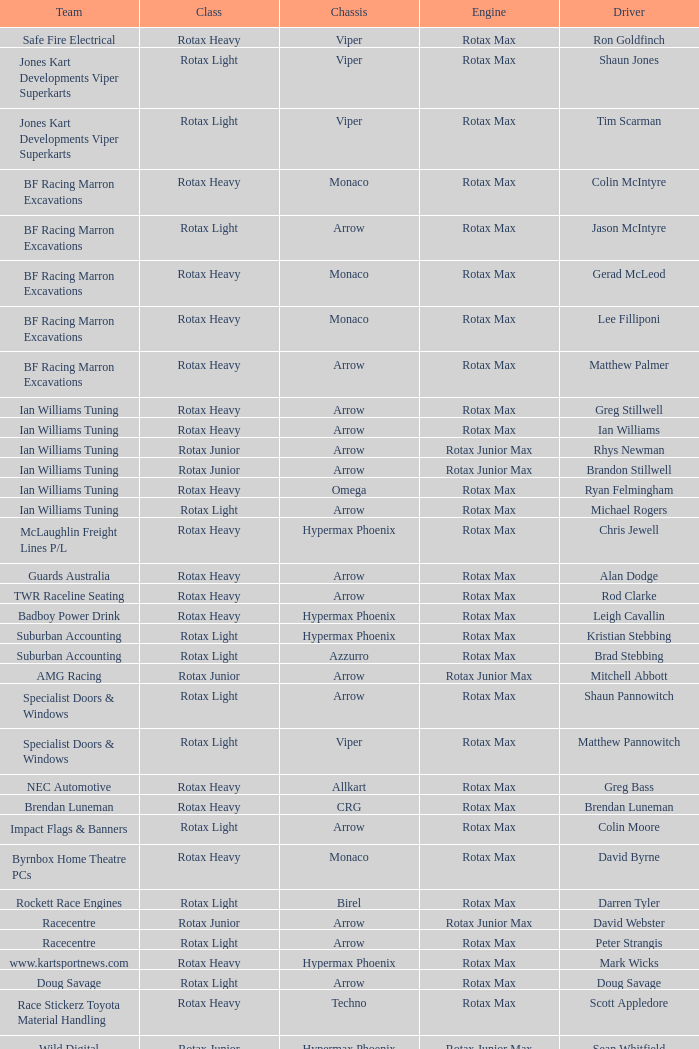What is the name of the squad belonging to the rotax light category? Jones Kart Developments Viper Superkarts, Jones Kart Developments Viper Superkarts, BF Racing Marron Excavations, Ian Williams Tuning, Suburban Accounting, Suburban Accounting, Specialist Doors & Windows, Specialist Doors & Windows, Impact Flags & Banners, Rockett Race Engines, Racecentre, Doug Savage. 